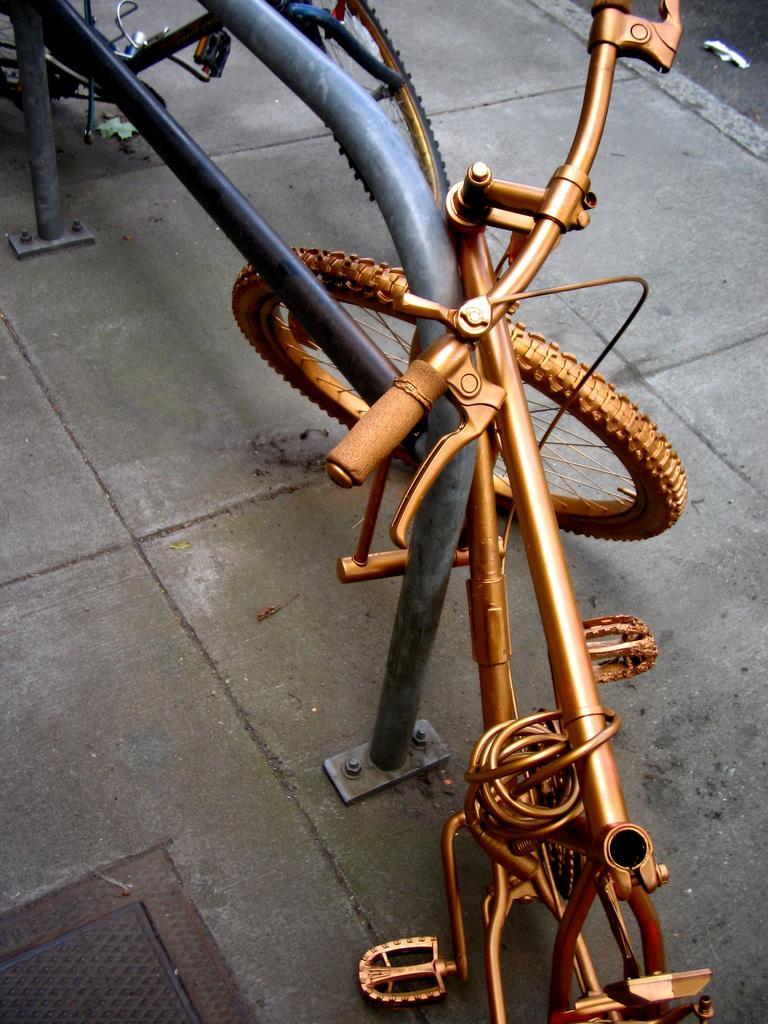Could you give a brief overview of what you see in this image? In this image we can see few bicycles. There is a metallic object in the image. There is a metal lid at the bottom of the image. 